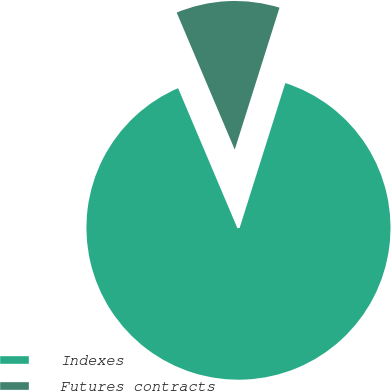Convert chart. <chart><loc_0><loc_0><loc_500><loc_500><pie_chart><fcel>Indexes<fcel>Futures contracts<nl><fcel>88.76%<fcel>11.24%<nl></chart> 